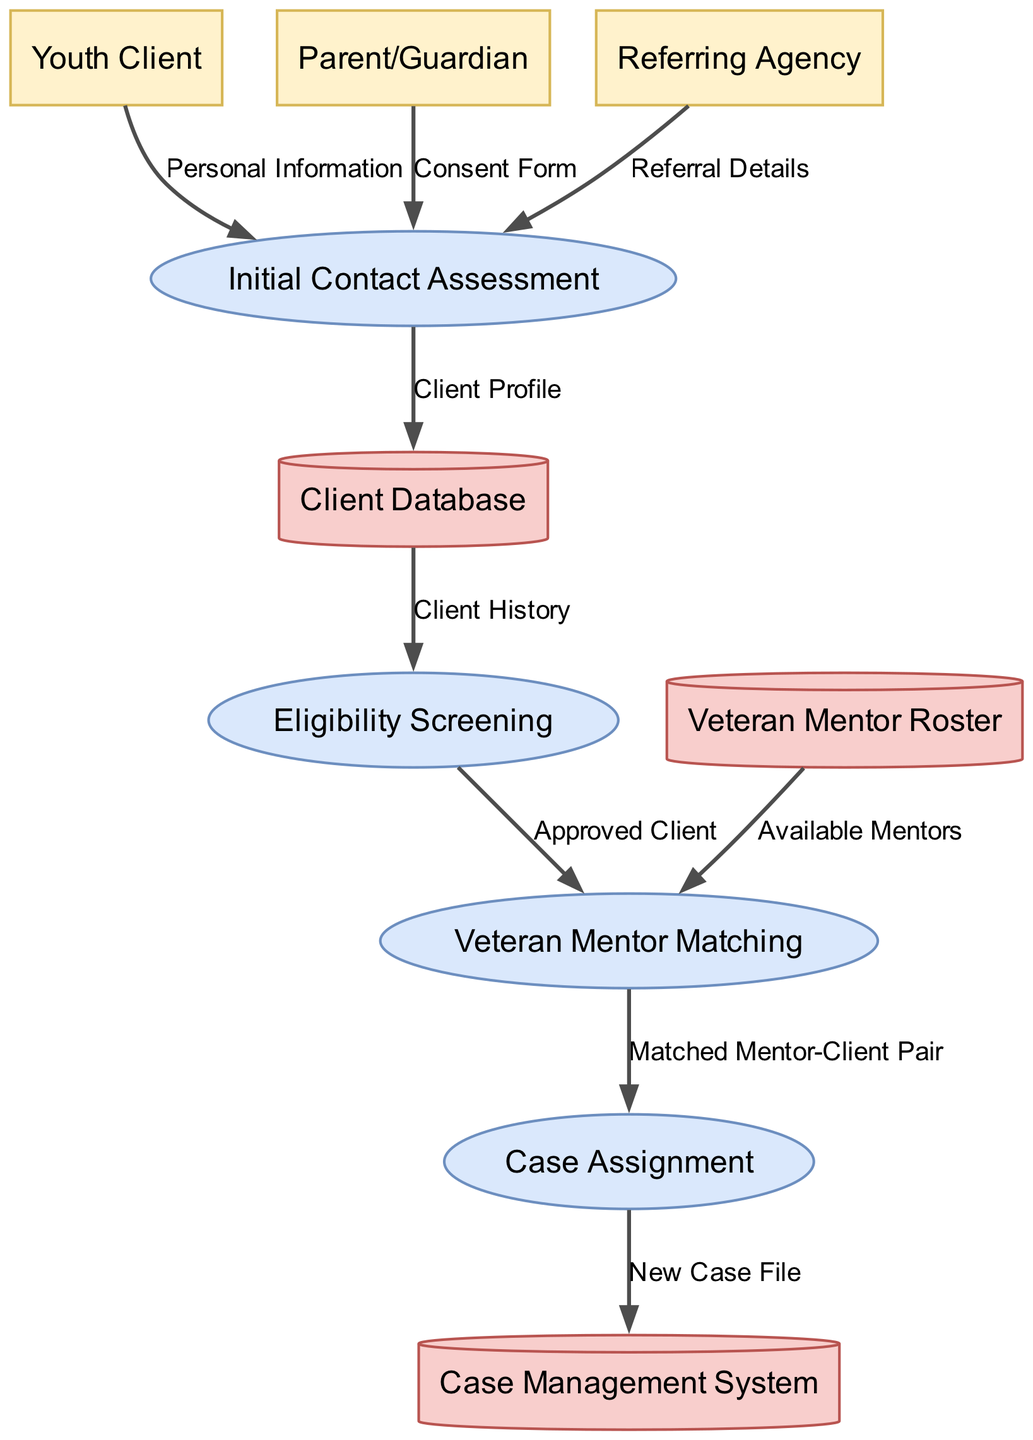What are the external entities in the diagram? The external entities are the sources of information or inputs to the processes illustrated in the diagram. The entities shown are Youth Client, Parent/Guardian, and Referring Agency.
Answer: Youth Client, Parent/Guardian, Referring Agency How many processes are involved in the intake process? The diagram contains a total of four processes that delineate the steps taken during the intake process. These are Initial Contact Assessment, Eligibility Screening, Veteran Mentor Matching, and Case Assignment.
Answer: 4 What type of data does the Youth Client provide? The data that the Youth Client provides is categorized under Personal Information, which is the input to the Initial Contact Assessment process.
Answer: Personal Information Which process receives the Referral Details? The process that receives the Referral Details is Initial Contact Assessment, as indicated by the data flow from the Referring Agency to this process.
Answer: Initial Contact Assessment What data is stored in the Client Database? The data stored in the Client Database is the Client Profile, which is created from the inputs gathered in the Initial Contact Assessment process.
Answer: Client Profile Which process leads to the Case Management System? The Case Assignment process leads to the Case Management System, which is where the New Case File is stored after assignment.
Answer: Case Assignment What kind of information flows from the Eligibility Screening to the Veteran Mentor Matching? The information that flows from the Eligibility Screening to the Veteran Mentor Matching is described as Approved Client, marking those qualified for mentorship.
Answer: Approved Client How many data stores are depicted in the diagram? The diagram includes three distinct data stores which are integral to managing the information processed during intake. These are Client Database, Veteran Mentor Roster, and Case Management System.
Answer: 3 What is the outcome of the Veteran Mentor Matching process? The outcome of the Veteran Mentor Matching process is the Matched Mentor-Client Pair, which signifies the successful pairing of a veteran mentor with an eligible youth client.
Answer: Matched Mentor-Client Pair 